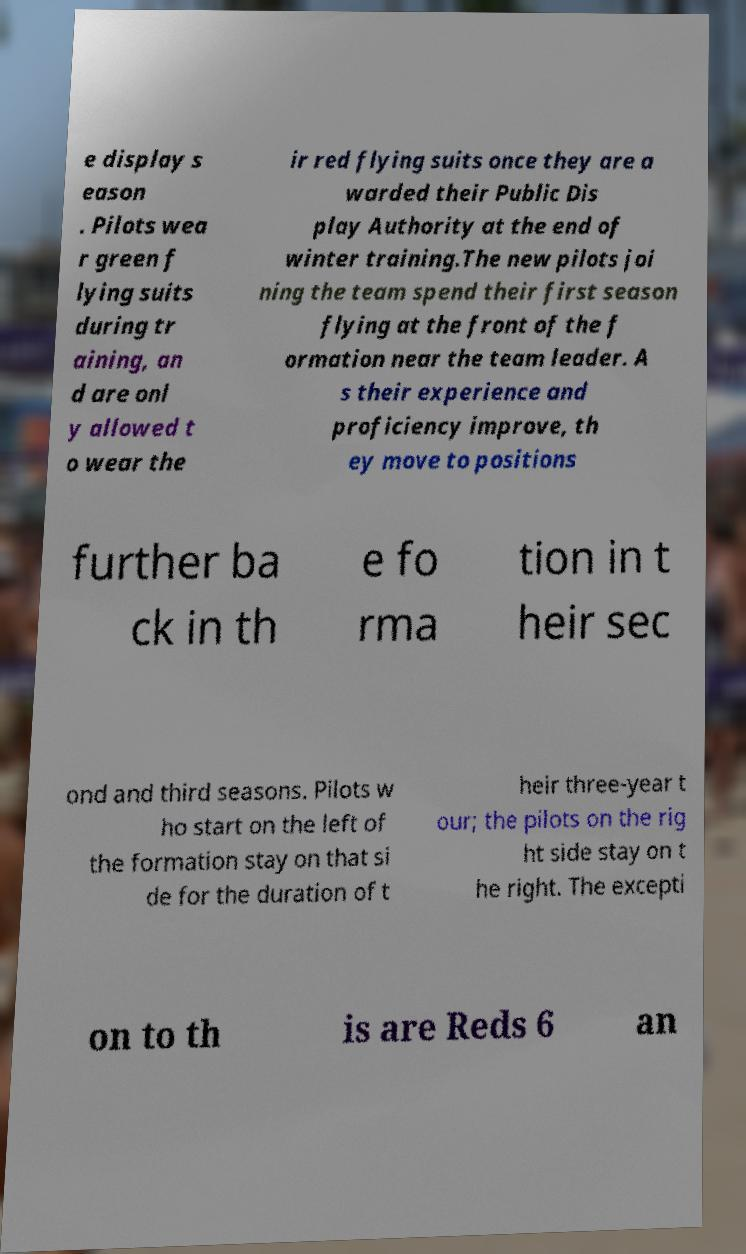I need the written content from this picture converted into text. Can you do that? e display s eason . Pilots wea r green f lying suits during tr aining, an d are onl y allowed t o wear the ir red flying suits once they are a warded their Public Dis play Authority at the end of winter training.The new pilots joi ning the team spend their first season flying at the front of the f ormation near the team leader. A s their experience and proficiency improve, th ey move to positions further ba ck in th e fo rma tion in t heir sec ond and third seasons. Pilots w ho start on the left of the formation stay on that si de for the duration of t heir three-year t our; the pilots on the rig ht side stay on t he right. The excepti on to th is are Reds 6 an 